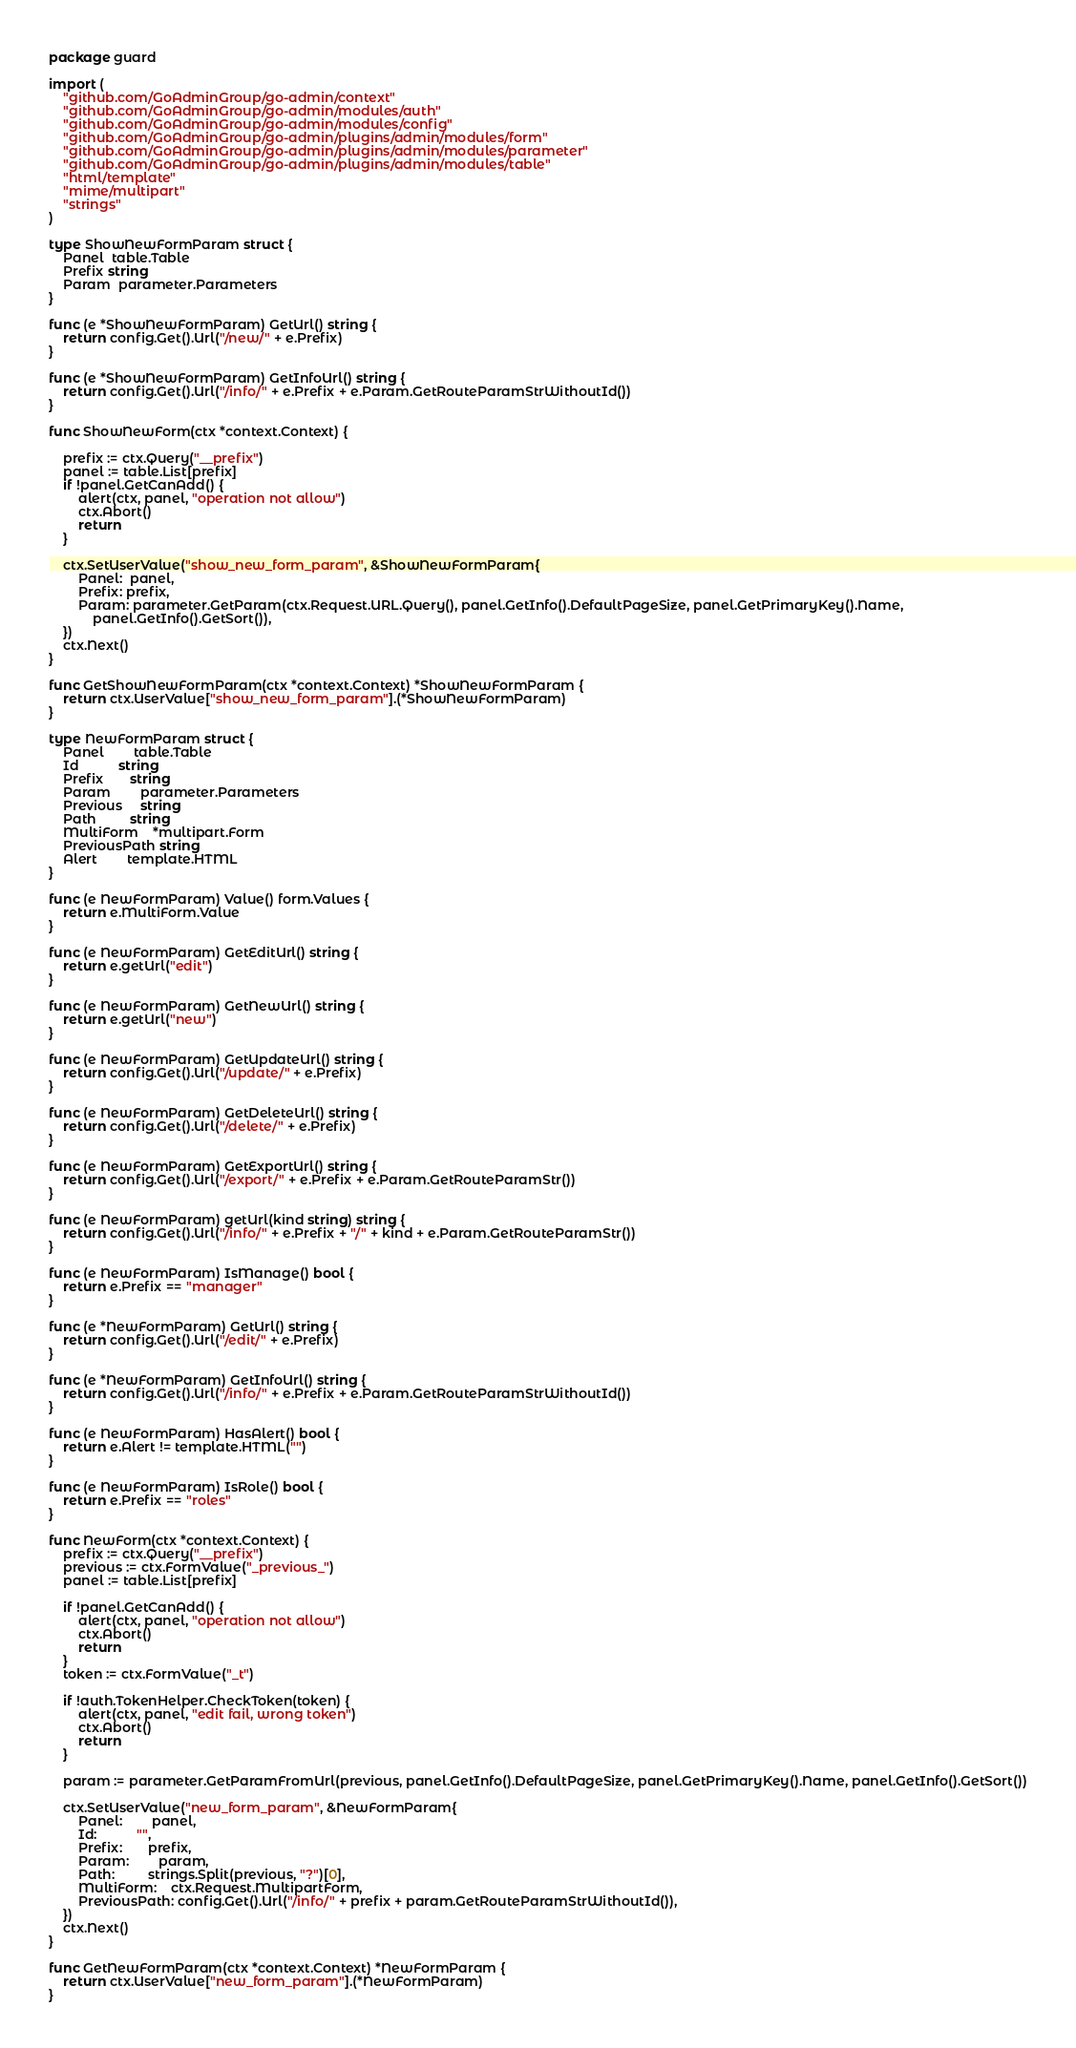Convert code to text. <code><loc_0><loc_0><loc_500><loc_500><_Go_>package guard

import (
	"github.com/GoAdminGroup/go-admin/context"
	"github.com/GoAdminGroup/go-admin/modules/auth"
	"github.com/GoAdminGroup/go-admin/modules/config"
	"github.com/GoAdminGroup/go-admin/plugins/admin/modules/form"
	"github.com/GoAdminGroup/go-admin/plugins/admin/modules/parameter"
	"github.com/GoAdminGroup/go-admin/plugins/admin/modules/table"
	"html/template"
	"mime/multipart"
	"strings"
)

type ShowNewFormParam struct {
	Panel  table.Table
	Prefix string
	Param  parameter.Parameters
}

func (e *ShowNewFormParam) GetUrl() string {
	return config.Get().Url("/new/" + e.Prefix)
}

func (e *ShowNewFormParam) GetInfoUrl() string {
	return config.Get().Url("/info/" + e.Prefix + e.Param.GetRouteParamStrWithoutId())
}

func ShowNewForm(ctx *context.Context) {

	prefix := ctx.Query("__prefix")
	panel := table.List[prefix]
	if !panel.GetCanAdd() {
		alert(ctx, panel, "operation not allow")
		ctx.Abort()
		return
	}

	ctx.SetUserValue("show_new_form_param", &ShowNewFormParam{
		Panel:  panel,
		Prefix: prefix,
		Param: parameter.GetParam(ctx.Request.URL.Query(), panel.GetInfo().DefaultPageSize, panel.GetPrimaryKey().Name,
			panel.GetInfo().GetSort()),
	})
	ctx.Next()
}

func GetShowNewFormParam(ctx *context.Context) *ShowNewFormParam {
	return ctx.UserValue["show_new_form_param"].(*ShowNewFormParam)
}

type NewFormParam struct {
	Panel        table.Table
	Id           string
	Prefix       string
	Param        parameter.Parameters
	Previous     string
	Path         string
	MultiForm    *multipart.Form
	PreviousPath string
	Alert        template.HTML
}

func (e NewFormParam) Value() form.Values {
	return e.MultiForm.Value
}

func (e NewFormParam) GetEditUrl() string {
	return e.getUrl("edit")
}

func (e NewFormParam) GetNewUrl() string {
	return e.getUrl("new")
}

func (e NewFormParam) GetUpdateUrl() string {
	return config.Get().Url("/update/" + e.Prefix)
}

func (e NewFormParam) GetDeleteUrl() string {
	return config.Get().Url("/delete/" + e.Prefix)
}

func (e NewFormParam) GetExportUrl() string {
	return config.Get().Url("/export/" + e.Prefix + e.Param.GetRouteParamStr())
}

func (e NewFormParam) getUrl(kind string) string {
	return config.Get().Url("/info/" + e.Prefix + "/" + kind + e.Param.GetRouteParamStr())
}

func (e NewFormParam) IsManage() bool {
	return e.Prefix == "manager"
}

func (e *NewFormParam) GetUrl() string {
	return config.Get().Url("/edit/" + e.Prefix)
}

func (e *NewFormParam) GetInfoUrl() string {
	return config.Get().Url("/info/" + e.Prefix + e.Param.GetRouteParamStrWithoutId())
}

func (e NewFormParam) HasAlert() bool {
	return e.Alert != template.HTML("")
}

func (e NewFormParam) IsRole() bool {
	return e.Prefix == "roles"
}

func NewForm(ctx *context.Context) {
	prefix := ctx.Query("__prefix")
	previous := ctx.FormValue("_previous_")
	panel := table.List[prefix]

	if !panel.GetCanAdd() {
		alert(ctx, panel, "operation not allow")
		ctx.Abort()
		return
	}
	token := ctx.FormValue("_t")

	if !auth.TokenHelper.CheckToken(token) {
		alert(ctx, panel, "edit fail, wrong token")
		ctx.Abort()
		return
	}

	param := parameter.GetParamFromUrl(previous, panel.GetInfo().DefaultPageSize, panel.GetPrimaryKey().Name, panel.GetInfo().GetSort())

	ctx.SetUserValue("new_form_param", &NewFormParam{
		Panel:        panel,
		Id:           "",
		Prefix:       prefix,
		Param:        param,
		Path:         strings.Split(previous, "?")[0],
		MultiForm:    ctx.Request.MultipartForm,
		PreviousPath: config.Get().Url("/info/" + prefix + param.GetRouteParamStrWithoutId()),
	})
	ctx.Next()
}

func GetNewFormParam(ctx *context.Context) *NewFormParam {
	return ctx.UserValue["new_form_param"].(*NewFormParam)
}
</code> 